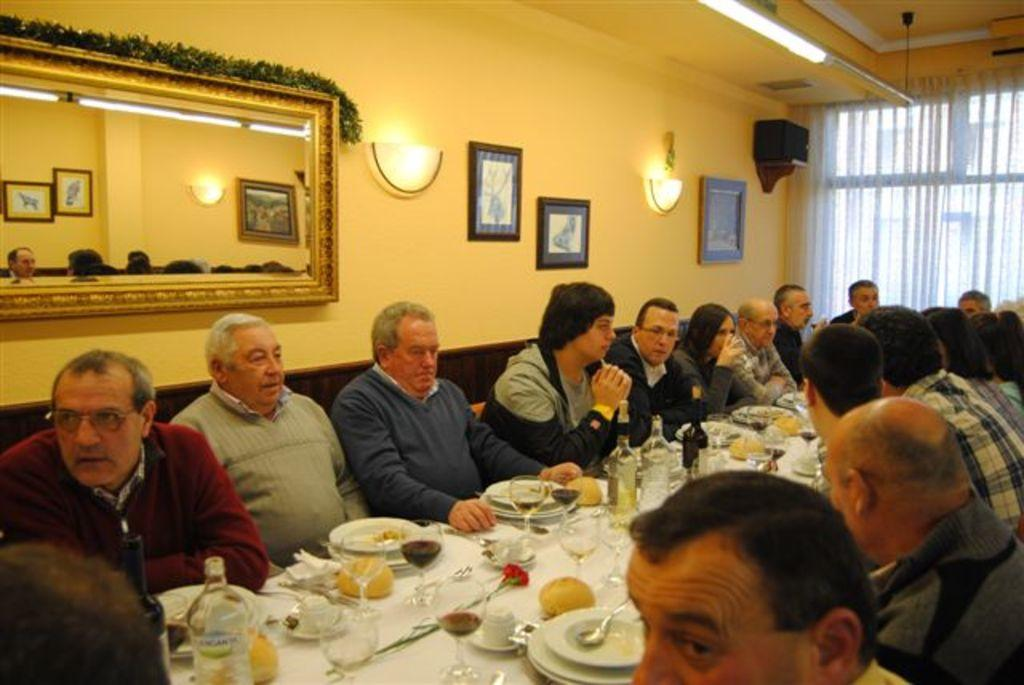What are the people in the image doing? People are seated on chairs around a table in the image. What objects can be seen on the table? There are glasses, plates, spoons, and food on the table. What is behind the people in the image? There is a mirror, a photo frame, and a light behind the people. Can you tell me how many grapes are on the table in the image? There is no mention of grapes in the image, so it is impossible to determine their presence or quantity. Is there a gun visible on the table in the image? No, there is no gun present on the table in the image. 